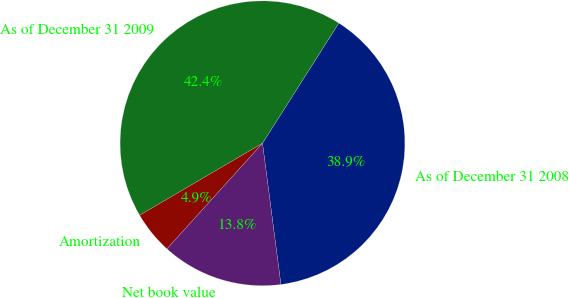Convert chart. <chart><loc_0><loc_0><loc_500><loc_500><pie_chart><fcel>As of December 31 2008<fcel>As of December 31 2009<fcel>Amortization<fcel>Net book value<nl><fcel>38.93%<fcel>42.44%<fcel>4.86%<fcel>13.77%<nl></chart> 